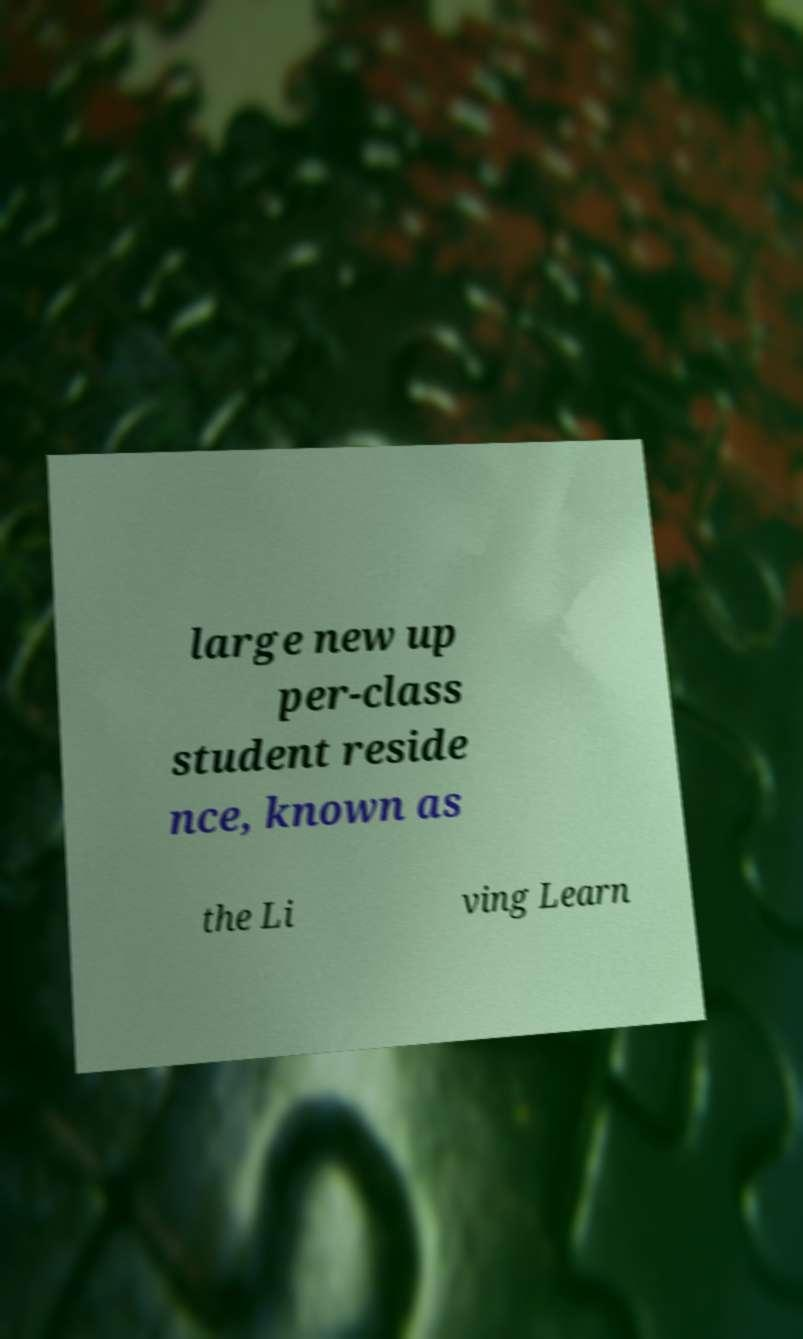Can you accurately transcribe the text from the provided image for me? large new up per-class student reside nce, known as the Li ving Learn 